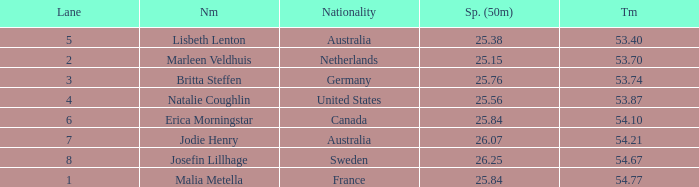What is the total of lane(s) for swimmers from Sweden with a 50m split of faster than 26.25? None. 